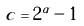Convert formula to latex. <formula><loc_0><loc_0><loc_500><loc_500>c = 2 ^ { \alpha } - 1</formula> 